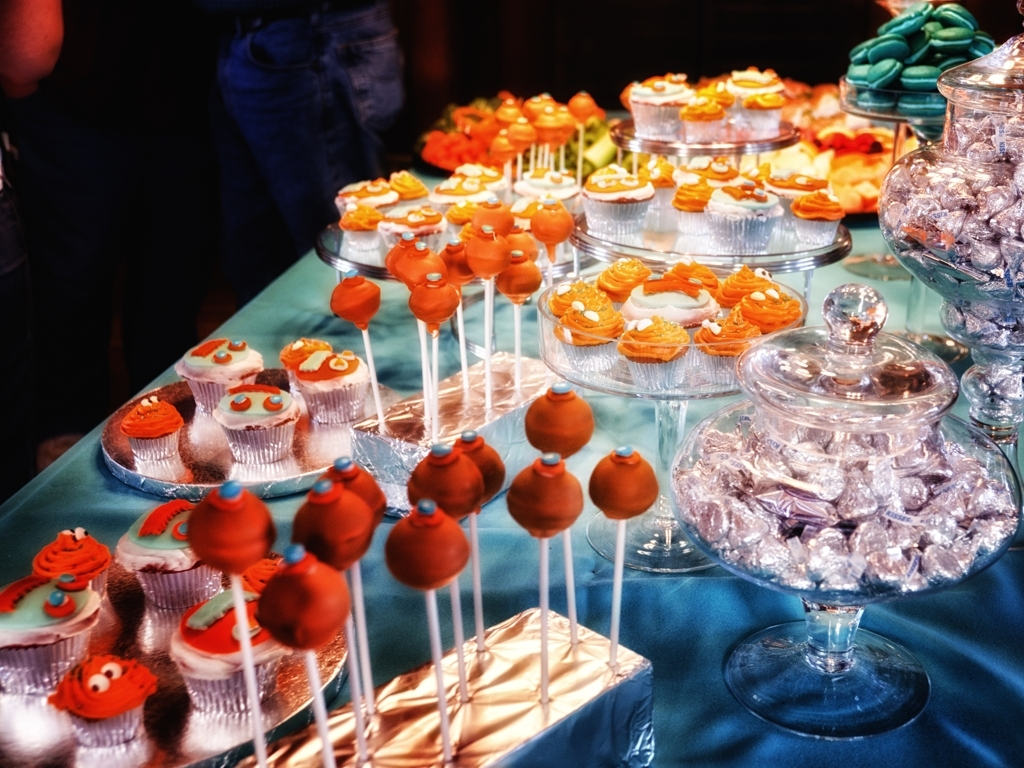How can the presentation of these treats influence the guests' experience at an event? The aesthetically pleasing arrangement on tiered stands enhances the visual appeal and creates a delightful focal point that can entice guests. The accessibility of the treats enables guests to easily pick and choose their preferred sweets, contributing to a pleasant and memorable experience. 